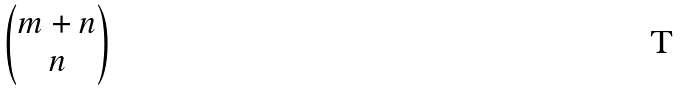Convert formula to latex. <formula><loc_0><loc_0><loc_500><loc_500>\begin{pmatrix} m + n \\ n \end{pmatrix}</formula> 